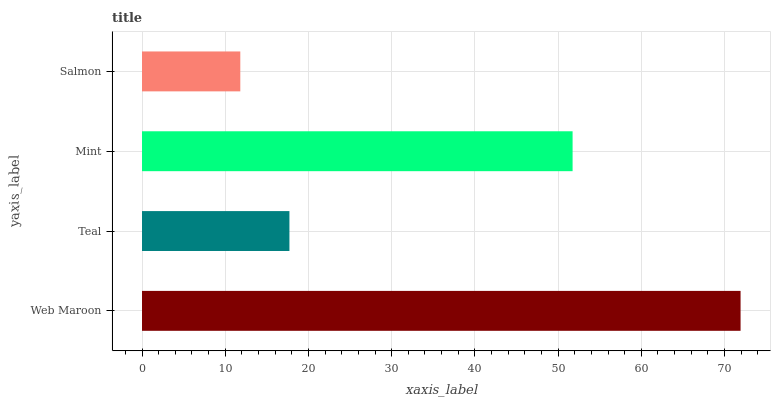Is Salmon the minimum?
Answer yes or no. Yes. Is Web Maroon the maximum?
Answer yes or no. Yes. Is Teal the minimum?
Answer yes or no. No. Is Teal the maximum?
Answer yes or no. No. Is Web Maroon greater than Teal?
Answer yes or no. Yes. Is Teal less than Web Maroon?
Answer yes or no. Yes. Is Teal greater than Web Maroon?
Answer yes or no. No. Is Web Maroon less than Teal?
Answer yes or no. No. Is Mint the high median?
Answer yes or no. Yes. Is Teal the low median?
Answer yes or no. Yes. Is Teal the high median?
Answer yes or no. No. Is Mint the low median?
Answer yes or no. No. 